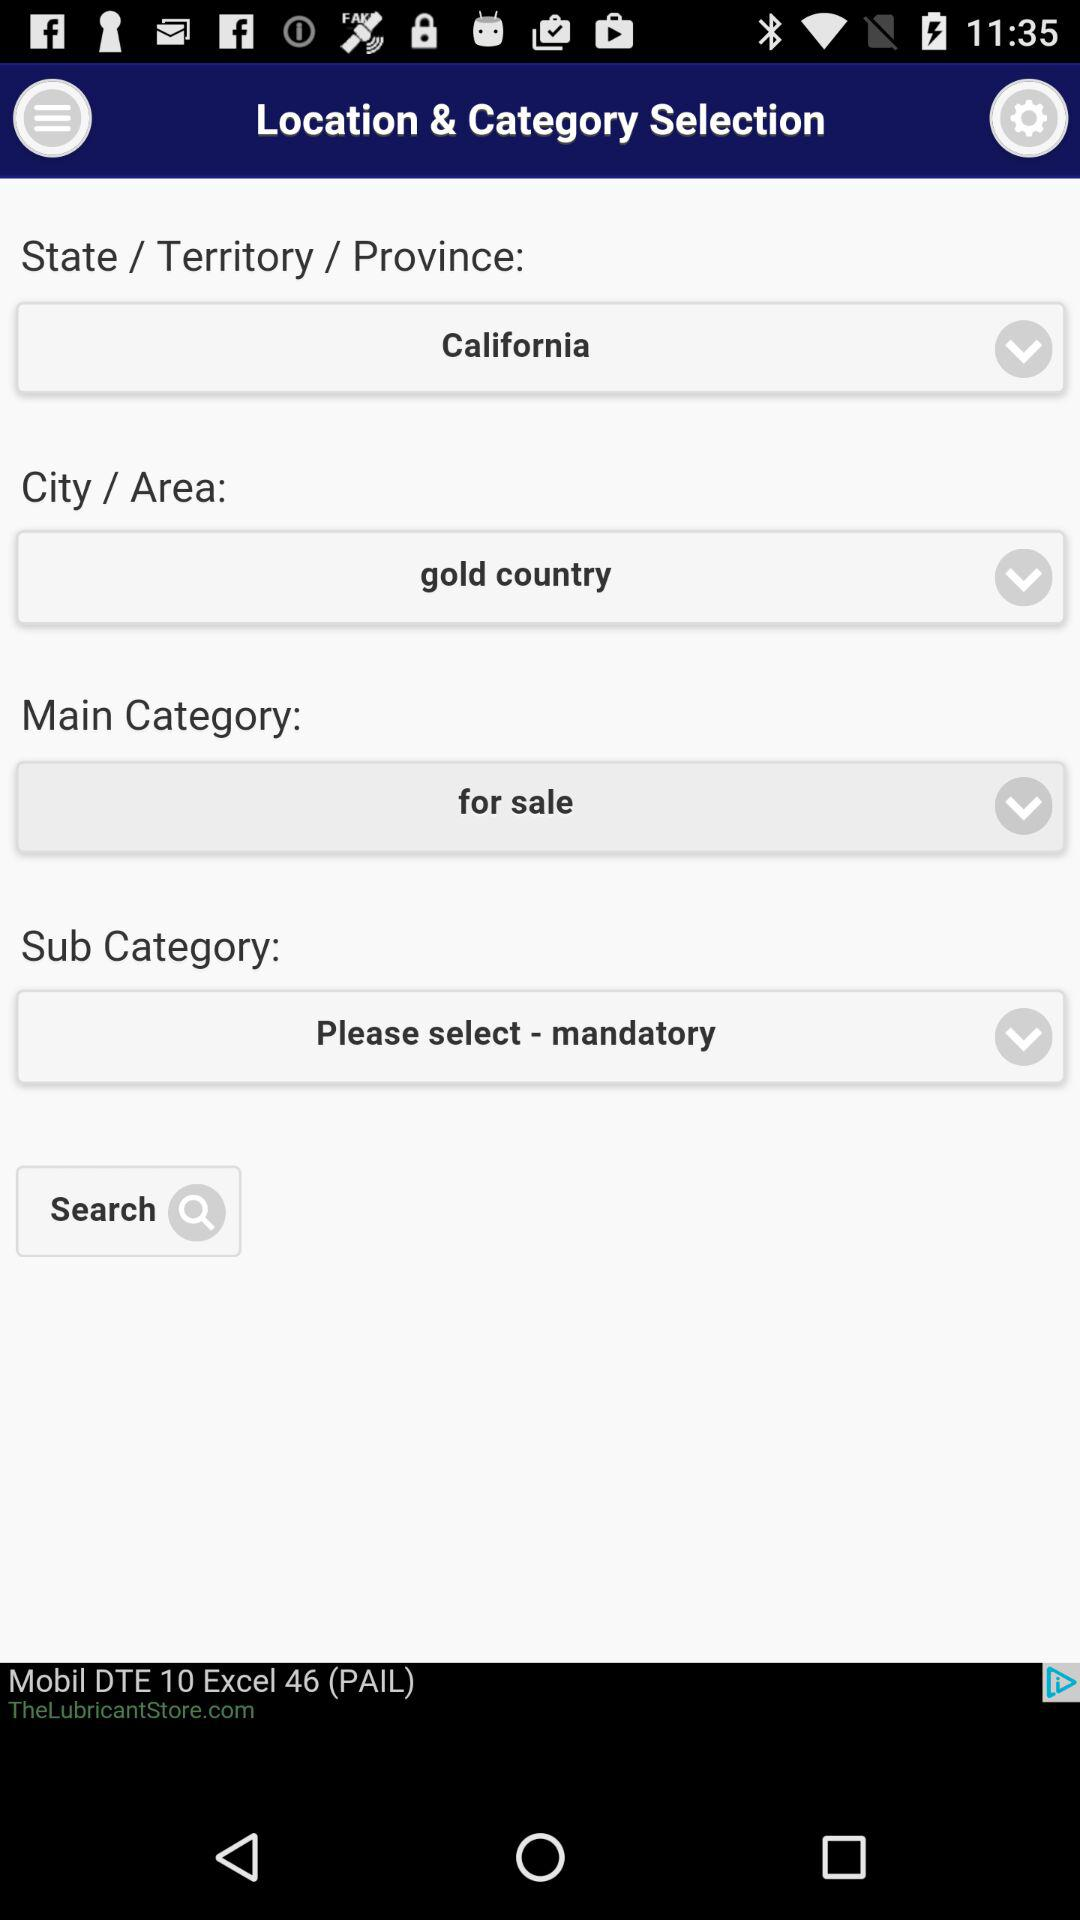What "Main Category" is selected? The selected category is "for sale". 